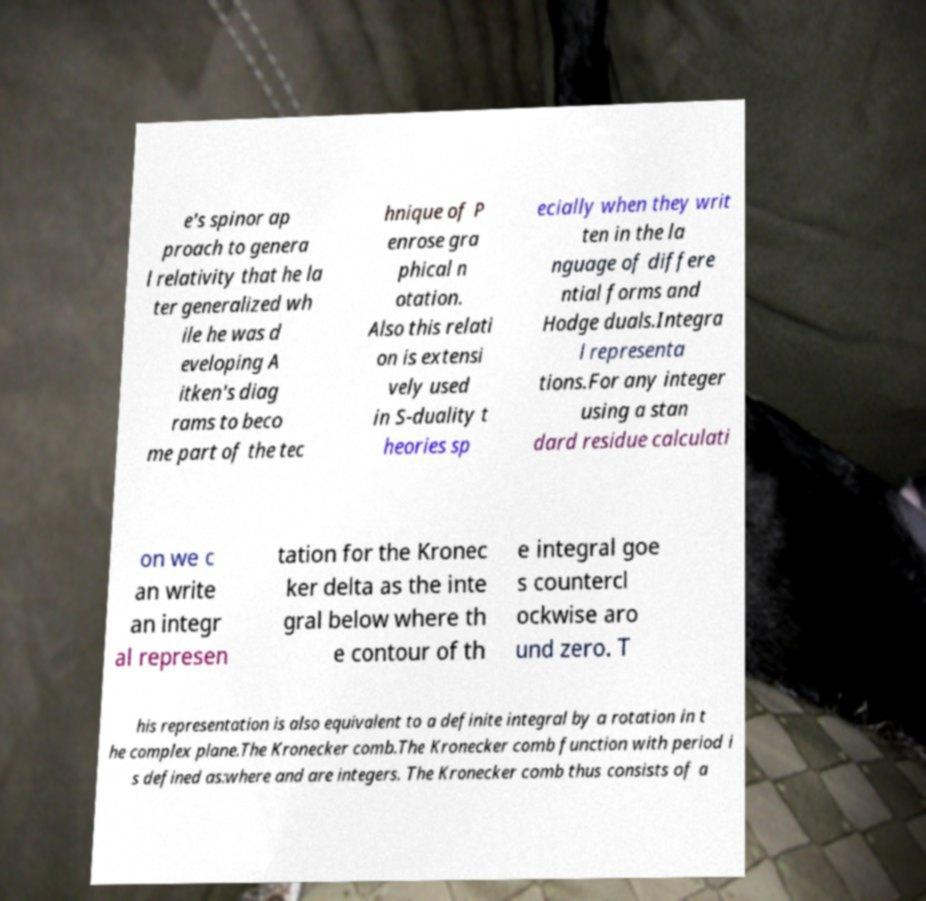Can you read and provide the text displayed in the image?This photo seems to have some interesting text. Can you extract and type it out for me? e's spinor ap proach to genera l relativity that he la ter generalized wh ile he was d eveloping A itken's diag rams to beco me part of the tec hnique of P enrose gra phical n otation. Also this relati on is extensi vely used in S-duality t heories sp ecially when they writ ten in the la nguage of differe ntial forms and Hodge duals.Integra l representa tions.For any integer using a stan dard residue calculati on we c an write an integr al represen tation for the Kronec ker delta as the inte gral below where th e contour of th e integral goe s countercl ockwise aro und zero. T his representation is also equivalent to a definite integral by a rotation in t he complex plane.The Kronecker comb.The Kronecker comb function with period i s defined as:where and are integers. The Kronecker comb thus consists of a 